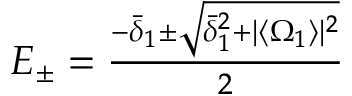Convert formula to latex. <formula><loc_0><loc_0><loc_500><loc_500>\begin{array} { r } { E _ { \pm } = \frac { - \bar { \delta } _ { 1 } \pm \sqrt { \bar { \delta } _ { 1 } ^ { 2 } + | \langle \Omega _ { 1 } \rangle | ^ { 2 } } } { 2 } } \end{array}</formula> 